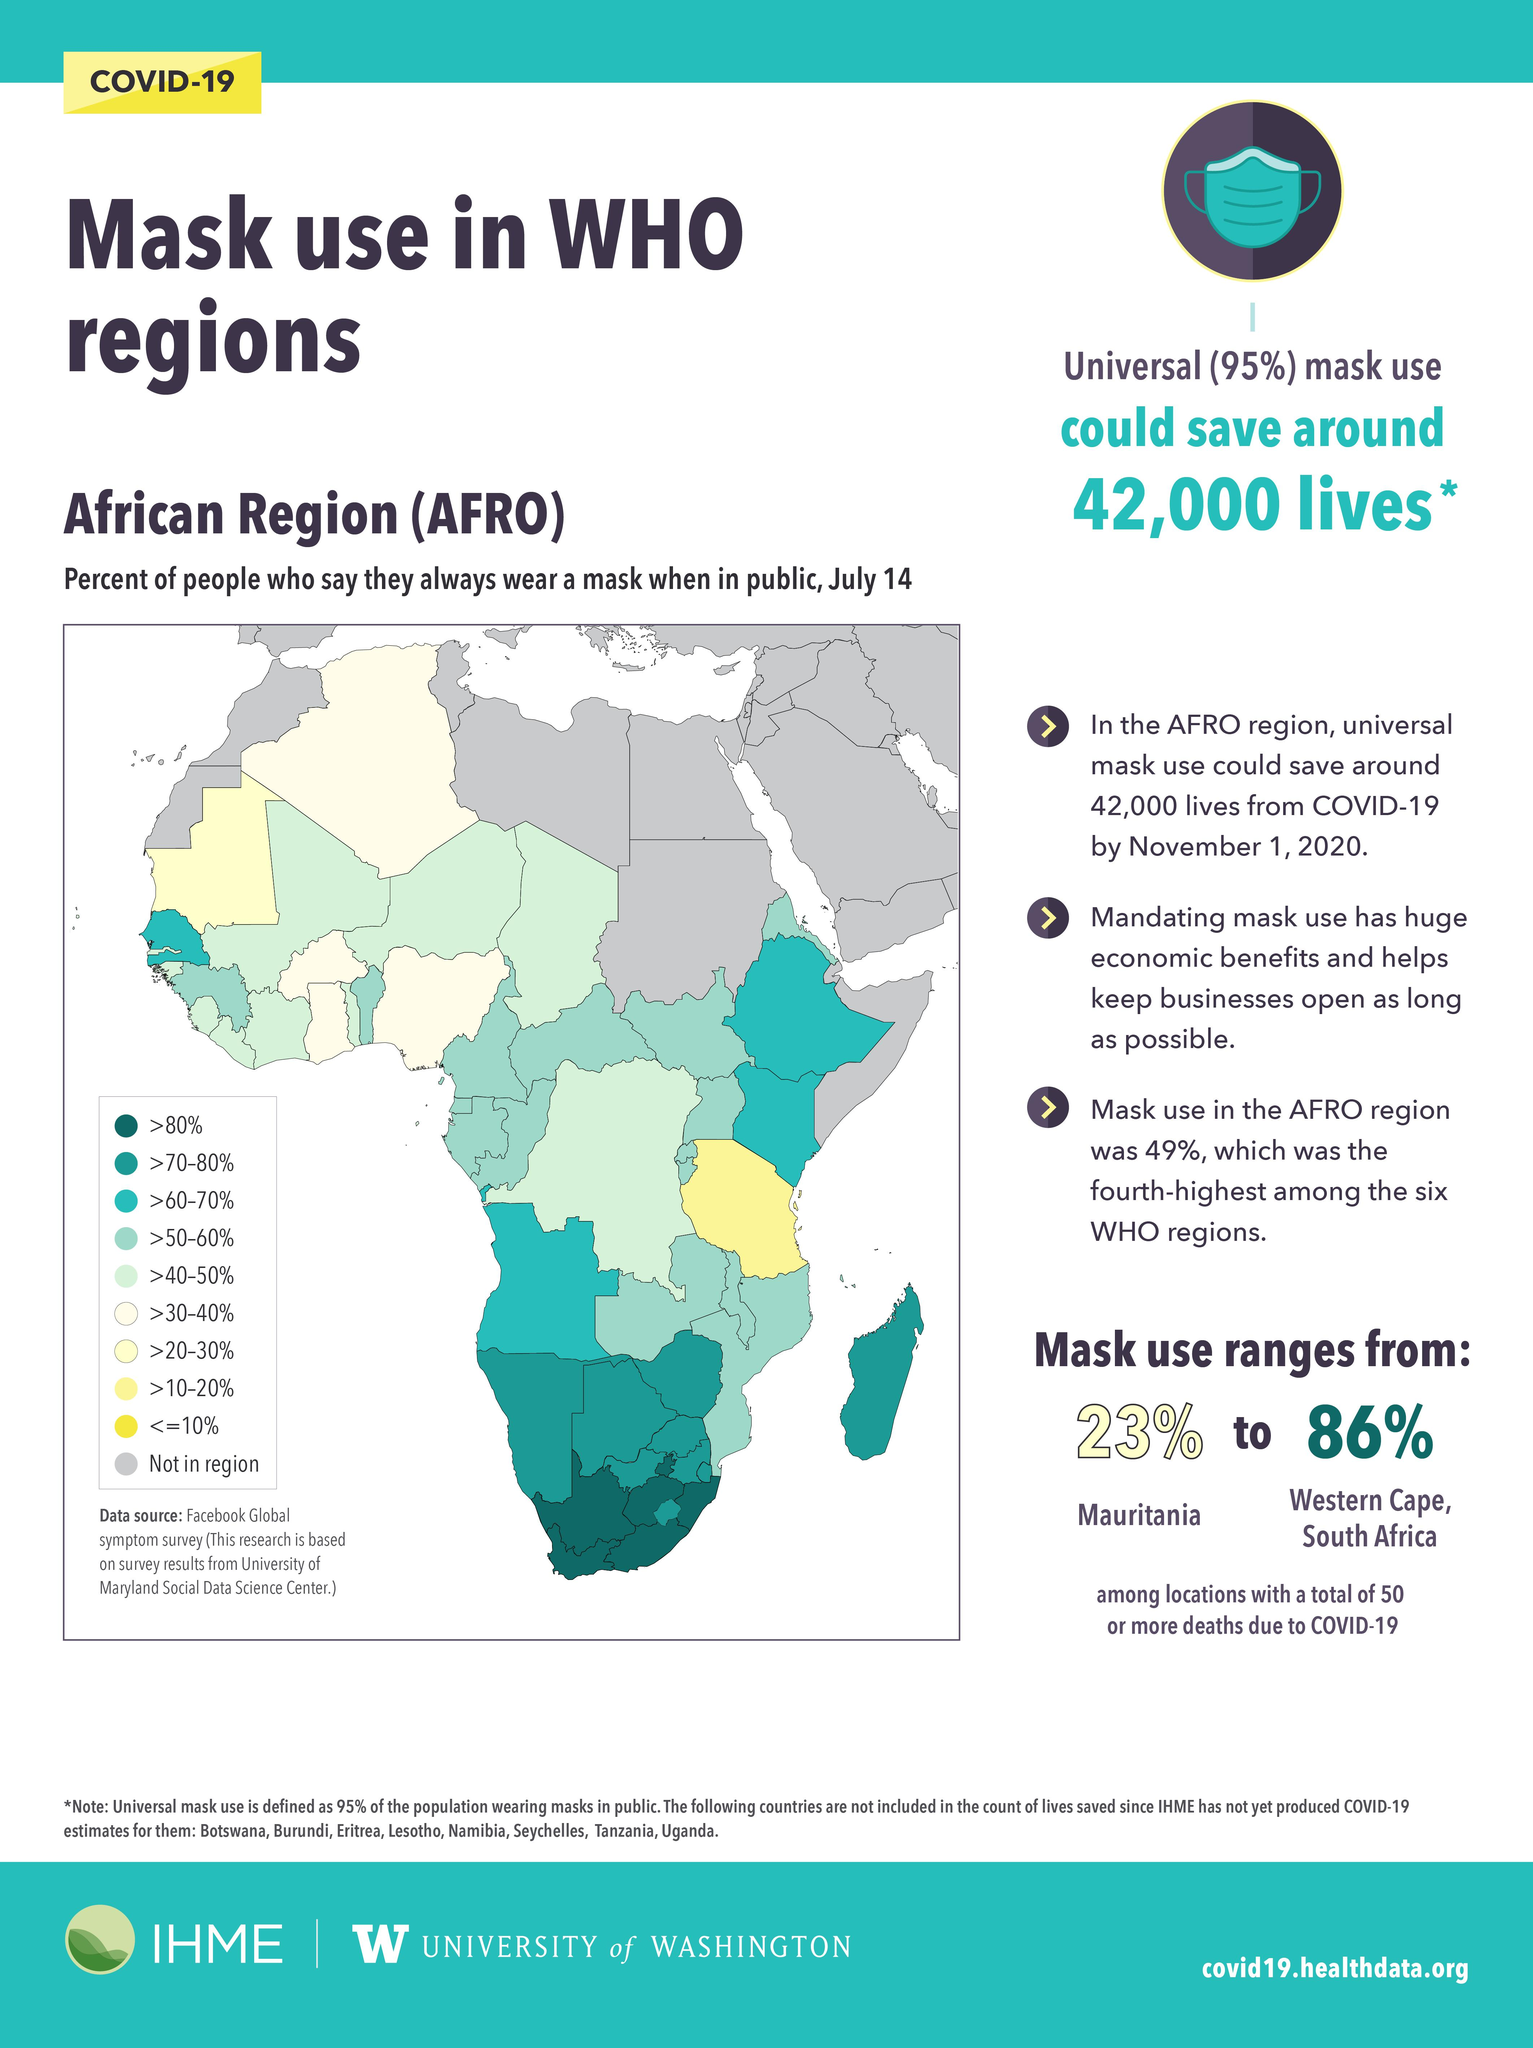Specify some key components in this picture. It is estimated that in at least 4 regions, over 60% to 70% of the population will always wear masks in public as a precaution against the spread of COVID-19. The Western Cape region in South Africa has the highest usage of masks in AFRO areas. 